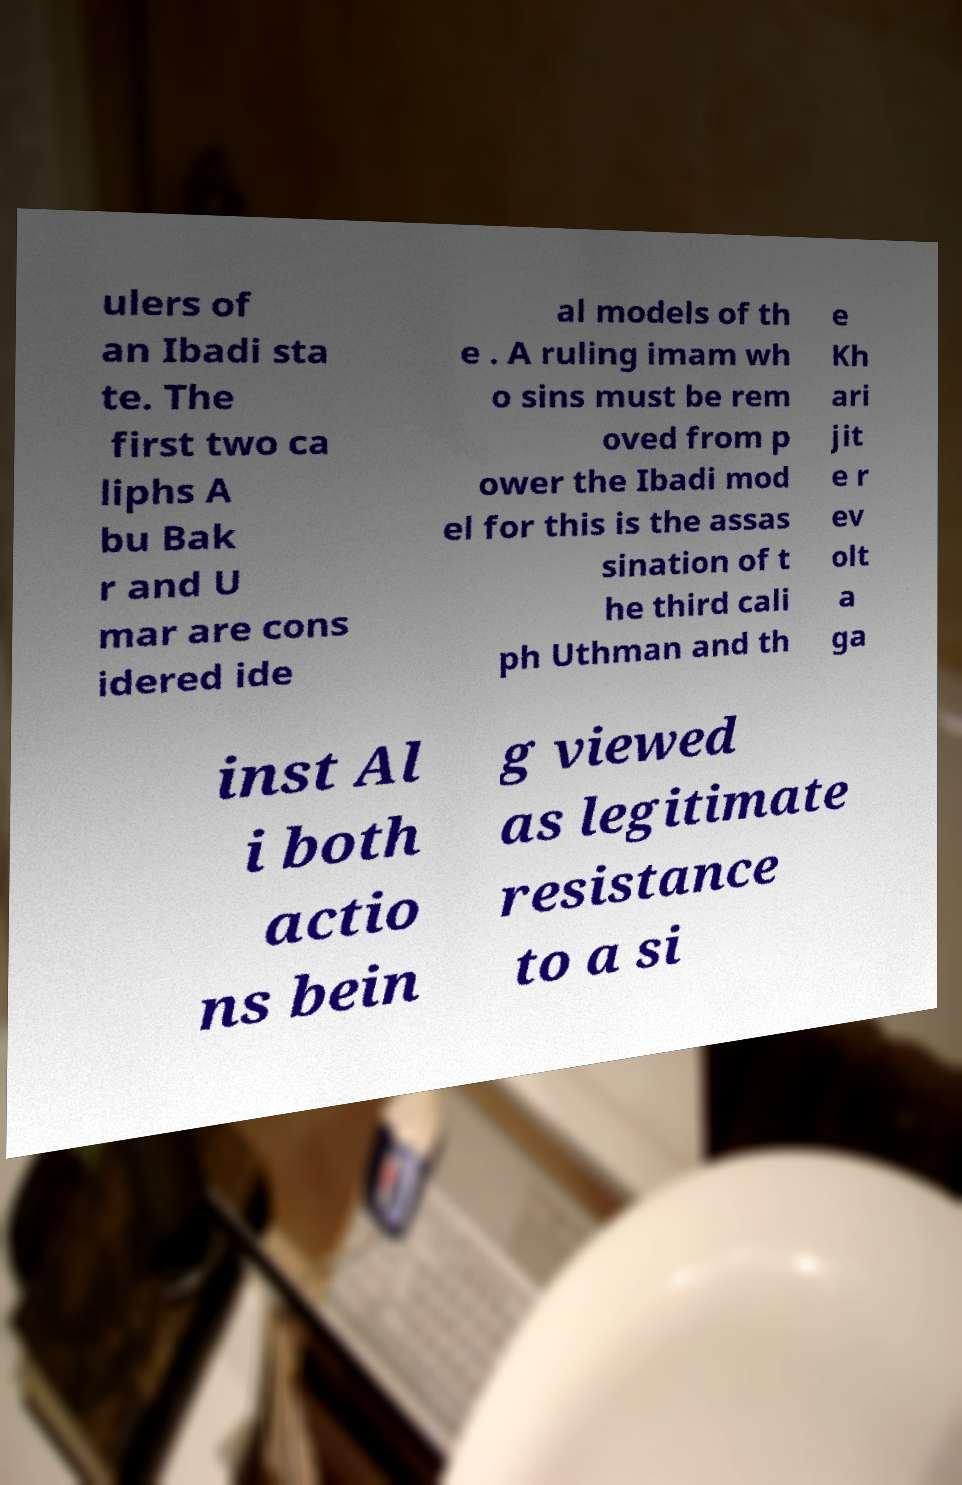For documentation purposes, I need the text within this image transcribed. Could you provide that? ulers of an Ibadi sta te. The first two ca liphs A bu Bak r and U mar are cons idered ide al models of th e . A ruling imam wh o sins must be rem oved from p ower the Ibadi mod el for this is the assas sination of t he third cali ph Uthman and th e Kh ari jit e r ev olt a ga inst Al i both actio ns bein g viewed as legitimate resistance to a si 